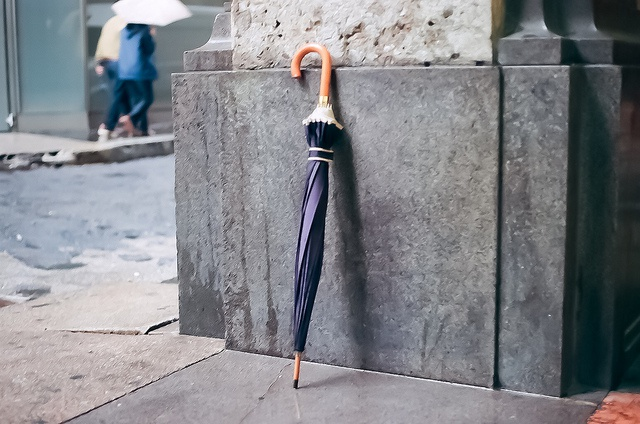Describe the objects in this image and their specific colors. I can see umbrella in gray, black, lightgray, and navy tones, people in gray, darkblue, navy, darkgray, and blue tones, people in gray, lightgray, blue, and darkblue tones, and umbrella in gray, white, darkgray, and lightgray tones in this image. 